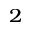Convert formula to latex. <formula><loc_0><loc_0><loc_500><loc_500>^ { 2 }</formula> 